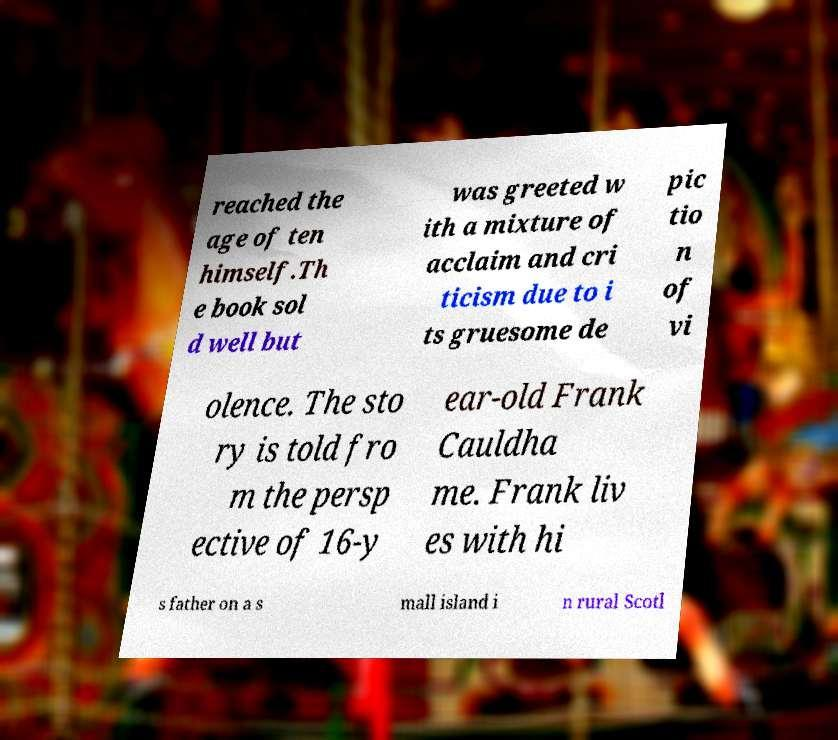Please identify and transcribe the text found in this image. reached the age of ten himself.Th e book sol d well but was greeted w ith a mixture of acclaim and cri ticism due to i ts gruesome de pic tio n of vi olence. The sto ry is told fro m the persp ective of 16-y ear-old Frank Cauldha me. Frank liv es with hi s father on a s mall island i n rural Scotl 